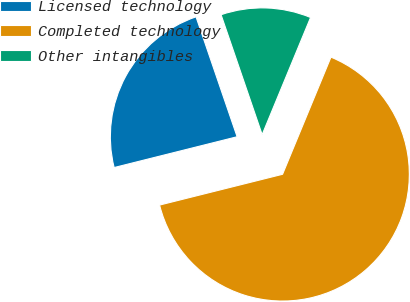<chart> <loc_0><loc_0><loc_500><loc_500><pie_chart><fcel>Licensed technology<fcel>Completed technology<fcel>Other intangibles<nl><fcel>23.65%<fcel>64.86%<fcel>11.49%<nl></chart> 